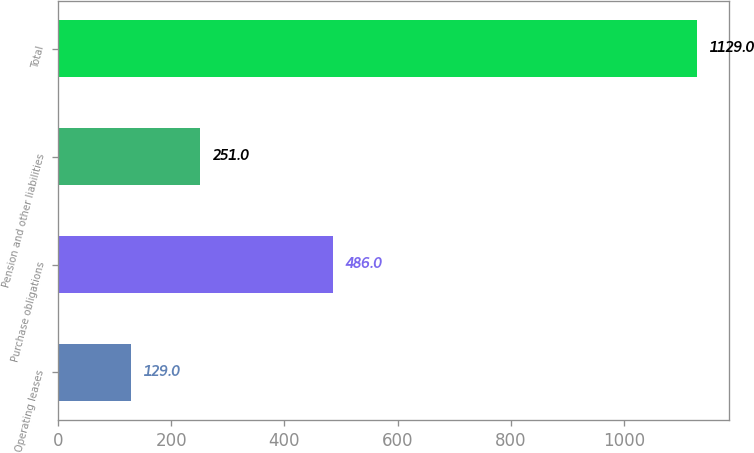<chart> <loc_0><loc_0><loc_500><loc_500><bar_chart><fcel>Operating leases<fcel>Purchase obligations<fcel>Pension and other liabilities<fcel>Total<nl><fcel>129<fcel>486<fcel>251<fcel>1129<nl></chart> 